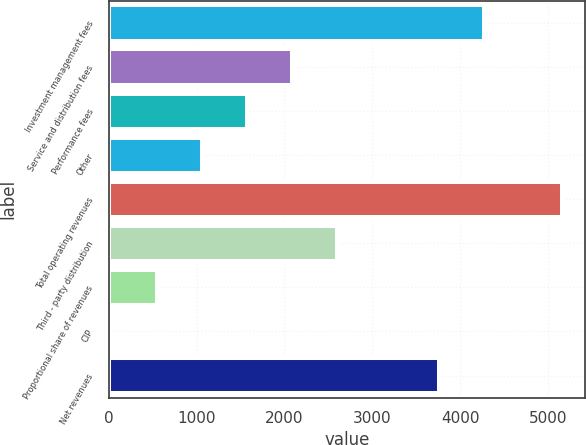Convert chart to OTSL. <chart><loc_0><loc_0><loc_500><loc_500><bar_chart><fcel>Investment management fees<fcel>Service and distribution fees<fcel>Performance fees<fcel>Other<fcel>Total operating revenues<fcel>Third - party distribution<fcel>Proportional share of revenues<fcel>CIP<fcel>Net revenues<nl><fcel>4267.69<fcel>2083.56<fcel>1570.77<fcel>1057.98<fcel>5160.3<fcel>2596.35<fcel>545.19<fcel>32.4<fcel>3754.9<nl></chart> 